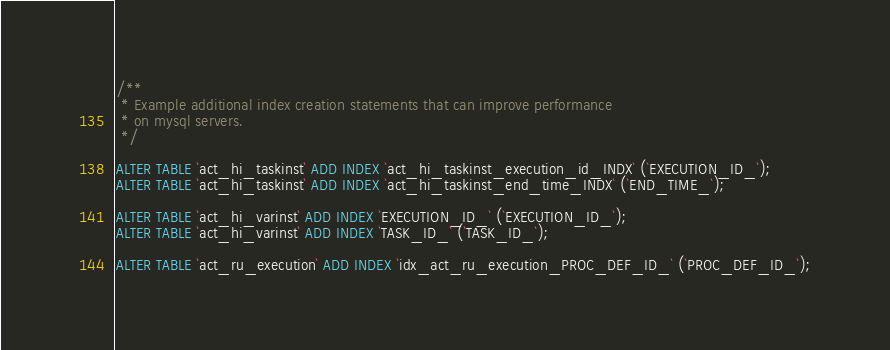Convert code to text. <code><loc_0><loc_0><loc_500><loc_500><_SQL_>/**
 * Example additional index creation statements that can improve performance 
 * on mysql servers.
 */

ALTER TABLE `act_hi_taskinst` ADD INDEX `act_hi_taskinst_execution_id_INDX` (`EXECUTION_ID_`);
ALTER TABLE `act_hi_taskinst` ADD INDEX `act_hi_taskinst_end_time_INDX` (`END_TIME_`);
		
ALTER TABLE `act_hi_varinst` ADD INDEX `EXECUTION_ID_` (`EXECUTION_ID_`);
ALTER TABLE `act_hi_varinst` ADD INDEX `TASK_ID_` (`TASK_ID_`);
	
ALTER TABLE `act_ru_execution` ADD INDEX `idx_act_ru_execution_PROC_DEF_ID_` (`PROC_DEF_ID_`);
</code> 